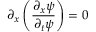Convert formula to latex. <formula><loc_0><loc_0><loc_500><loc_500>\partial _ { x } \left ( \frac { \partial _ { x } \psi } { \partial _ { t } \psi } \right ) = 0</formula> 